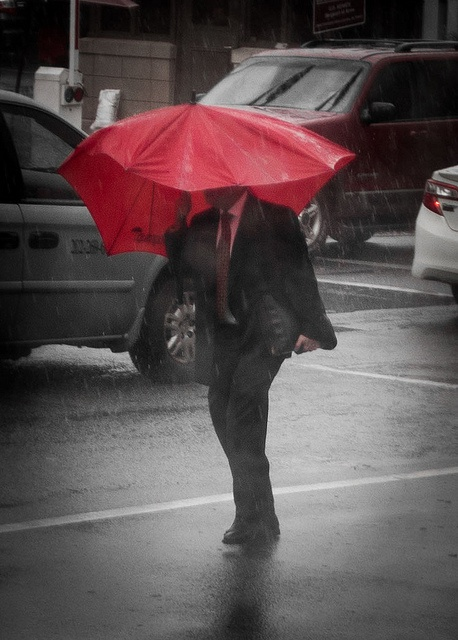Describe the objects in this image and their specific colors. I can see truck in darkgray, black, gray, and maroon tones, truck in darkgray, black, and gray tones, car in darkgray, black, gray, and maroon tones, people in darkgray, black, gray, and maroon tones, and umbrella in darkgray, brown, and maroon tones in this image. 